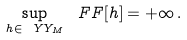Convert formula to latex. <formula><loc_0><loc_0><loc_500><loc_500>\sup _ { h \in \ Y Y _ { M } } \ F F [ h ] = + \infty \, .</formula> 